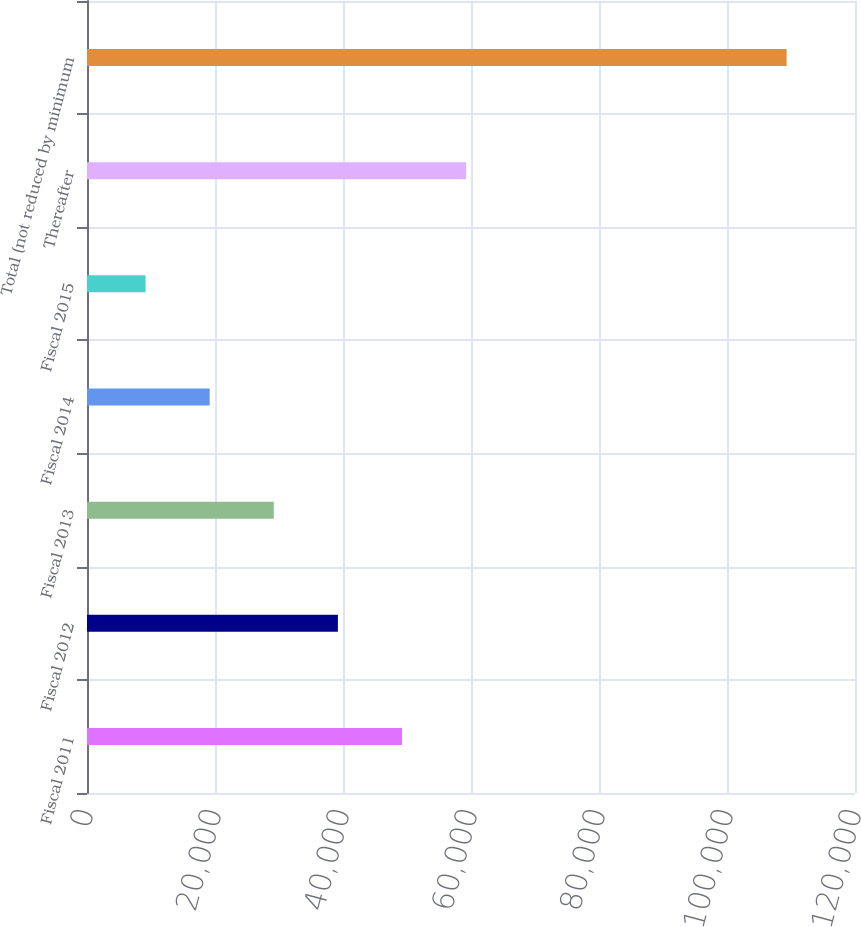Convert chart. <chart><loc_0><loc_0><loc_500><loc_500><bar_chart><fcel>Fiscal 2011<fcel>Fiscal 2012<fcel>Fiscal 2013<fcel>Fiscal 2014<fcel>Fiscal 2015<fcel>Thereafter<fcel>Total (not reduced by minimum<nl><fcel>49218.6<fcel>39202.7<fcel>29186.8<fcel>19170.9<fcel>9155<fcel>59234.5<fcel>109314<nl></chart> 